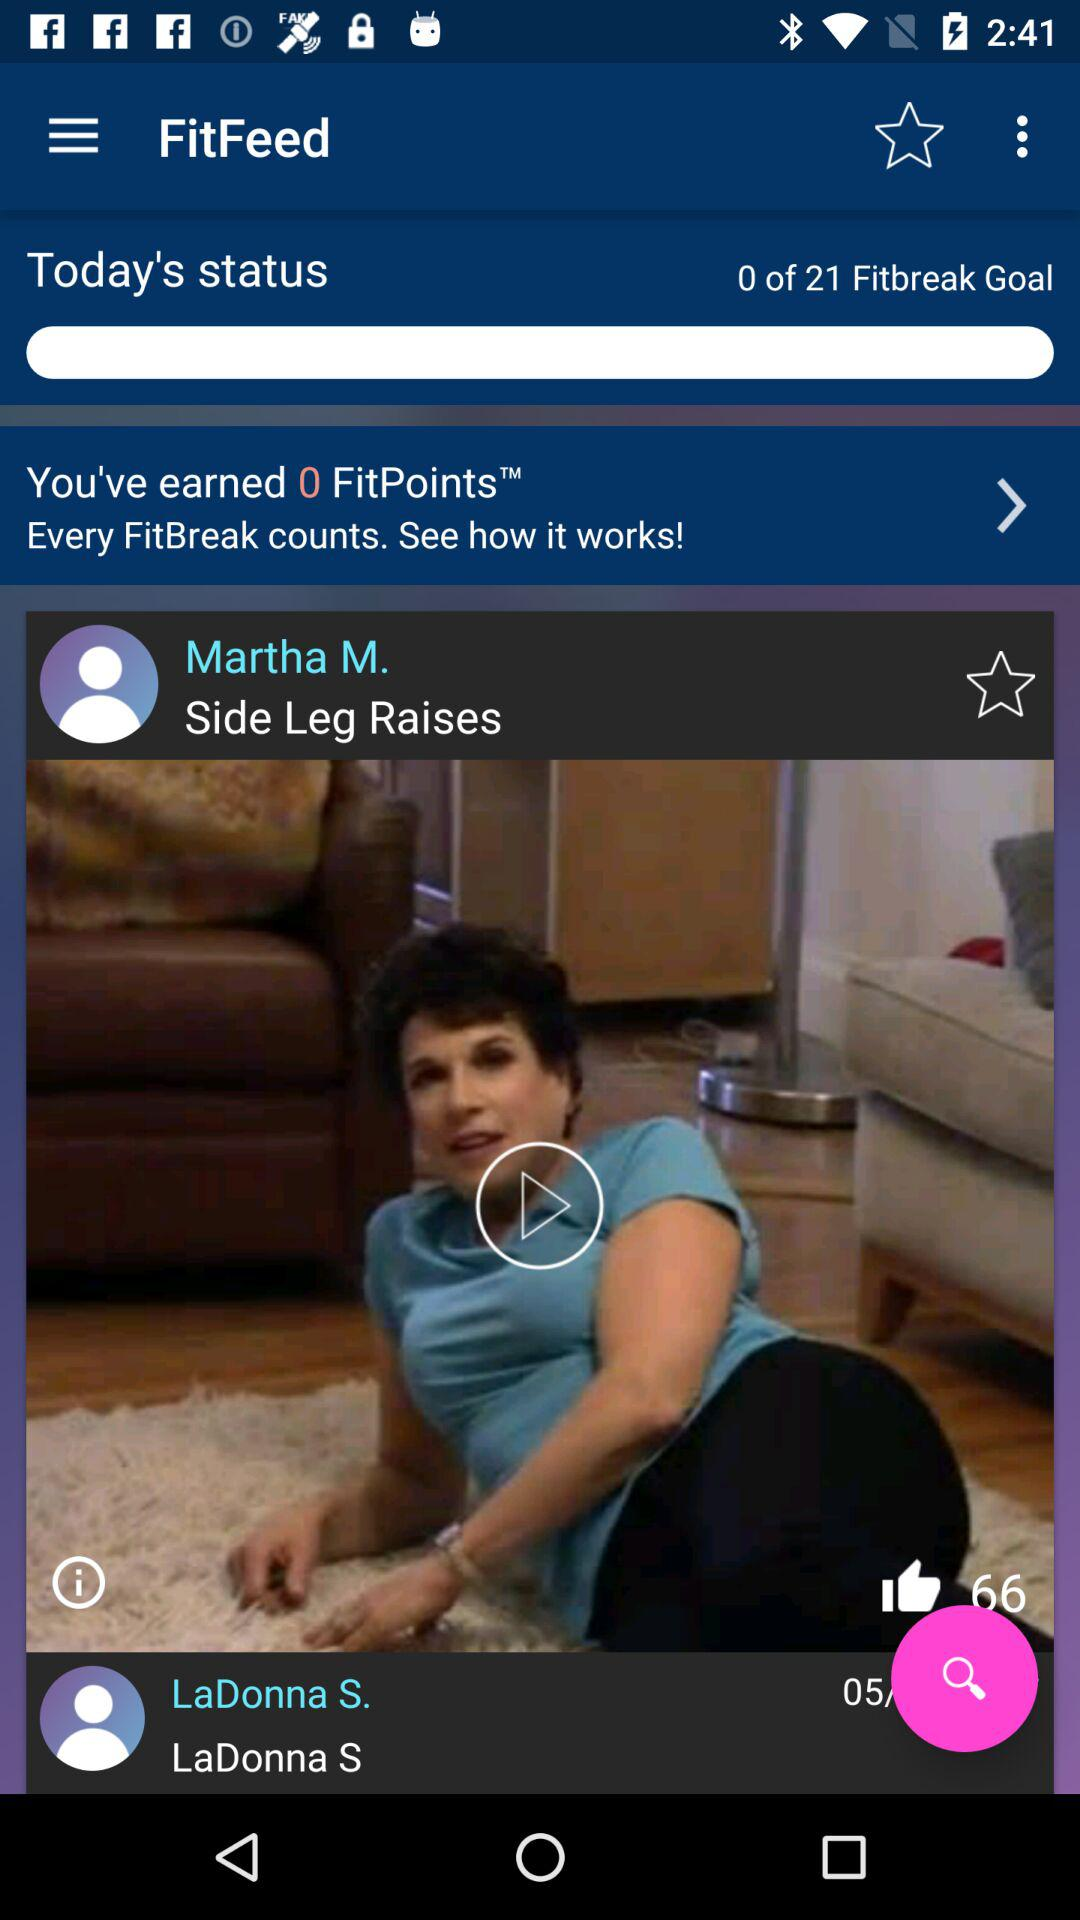How many Fitbreaks do I need to complete?
Answer the question using a single word or phrase. 21 